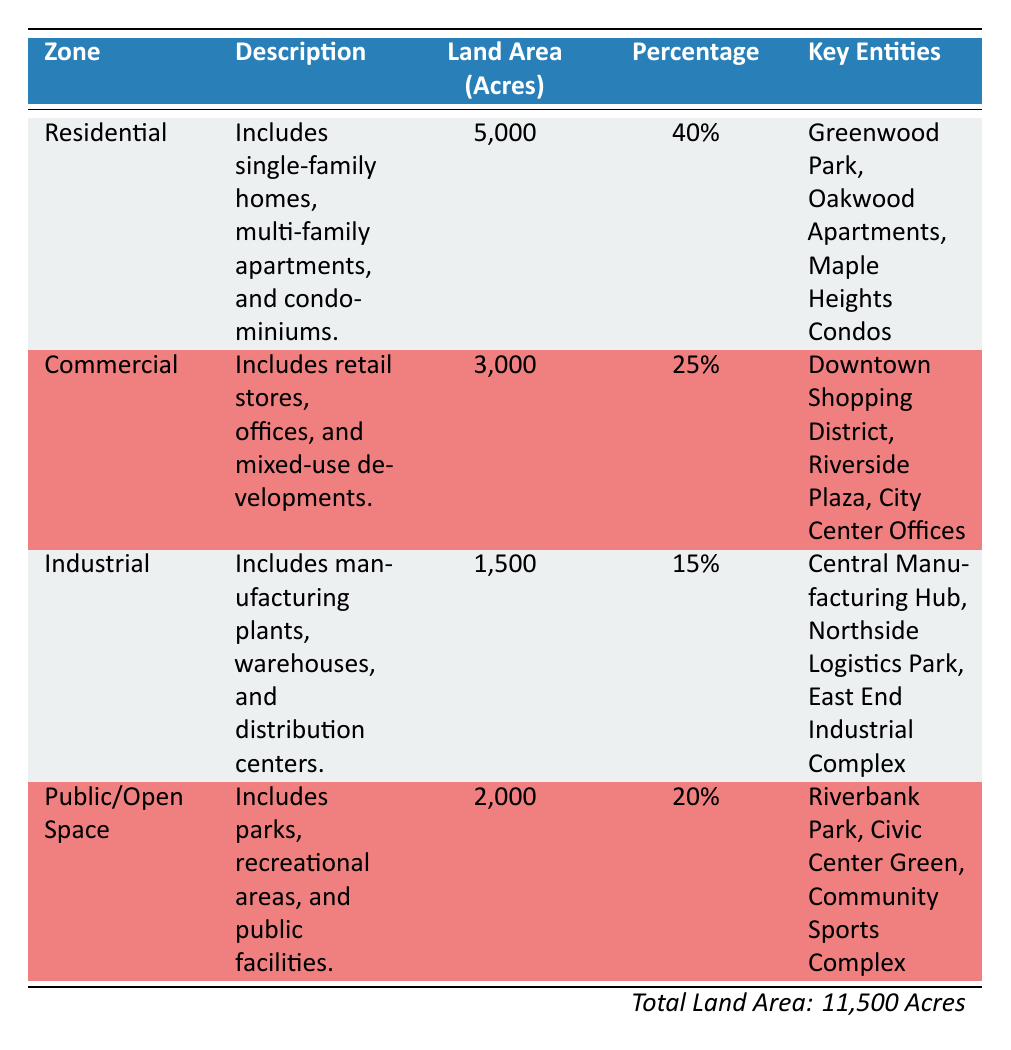What is the total land area for commercial zoning? The table specifies that the land area for commercial zoning is 3,000 acres.
Answer: 3,000 acres What percentage of total land is allocated for residential use? The table indicates that residential use occupies 40% of the total land area.
Answer: 40% How many acres are designated for industrial land use? According to the table, the industrial land area is 1,500 acres.
Answer: 1,500 acres Is the public/open space more than or less than 25% of the total land area? The table shows that public/open space occupies 20% of the total land area, which is less than 25%.
Answer: Less than What is the combined land area of residential and public/open space? The land area for residential is 5,000 acres, and for public/open space, it is 2,000 acres. Adding these gives 5,000 + 2,000 = 7,000 acres.
Answer: 7,000 acres Which zoning type has the least land area? By examining the land areas, industrial has the least at 1,500 acres compared to the others: 5,000 (residential), 3,000 (commercial), and 2,000 (public/open space).
Answer: Industrial What would be the average land area per zoning type? There are four zoning types with a total land area of 11,500 acres. To find the average: 11,500 / 4 = 2,875 acres.
Answer: 2,875 acres Is there a zoning type that occupies exactly 15% of the total land area? The table states that industrial occupies 15% of total land area. So, it is true that one zoning type has this percentage.
Answer: Yes What is the difference in land area between residential and commercial zones? The residential area is 5,000 acres and commercial is 3,000 acres. The difference is 5,000 - 3,000 = 2,000 acres.
Answer: 2,000 acres What is the total percentage of land allocated for commercial and industrial combined? Commercial is 25% and industrial is 15%. Adding these yields 25 + 15 = 40%.
Answer: 40% 